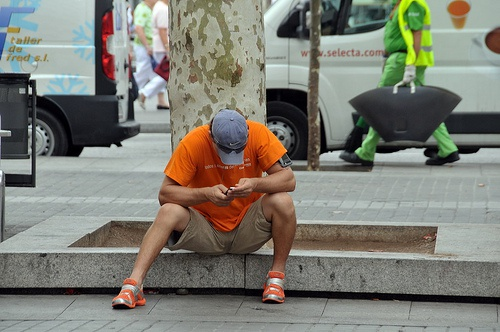Describe the objects in this image and their specific colors. I can see truck in darkgray, black, gray, and lightgray tones, people in darkgray, maroon, and gray tones, truck in darkgray, black, lightblue, and gray tones, people in darkgray, green, darkgreen, black, and lime tones, and handbag in darkgray, black, gray, and purple tones in this image. 